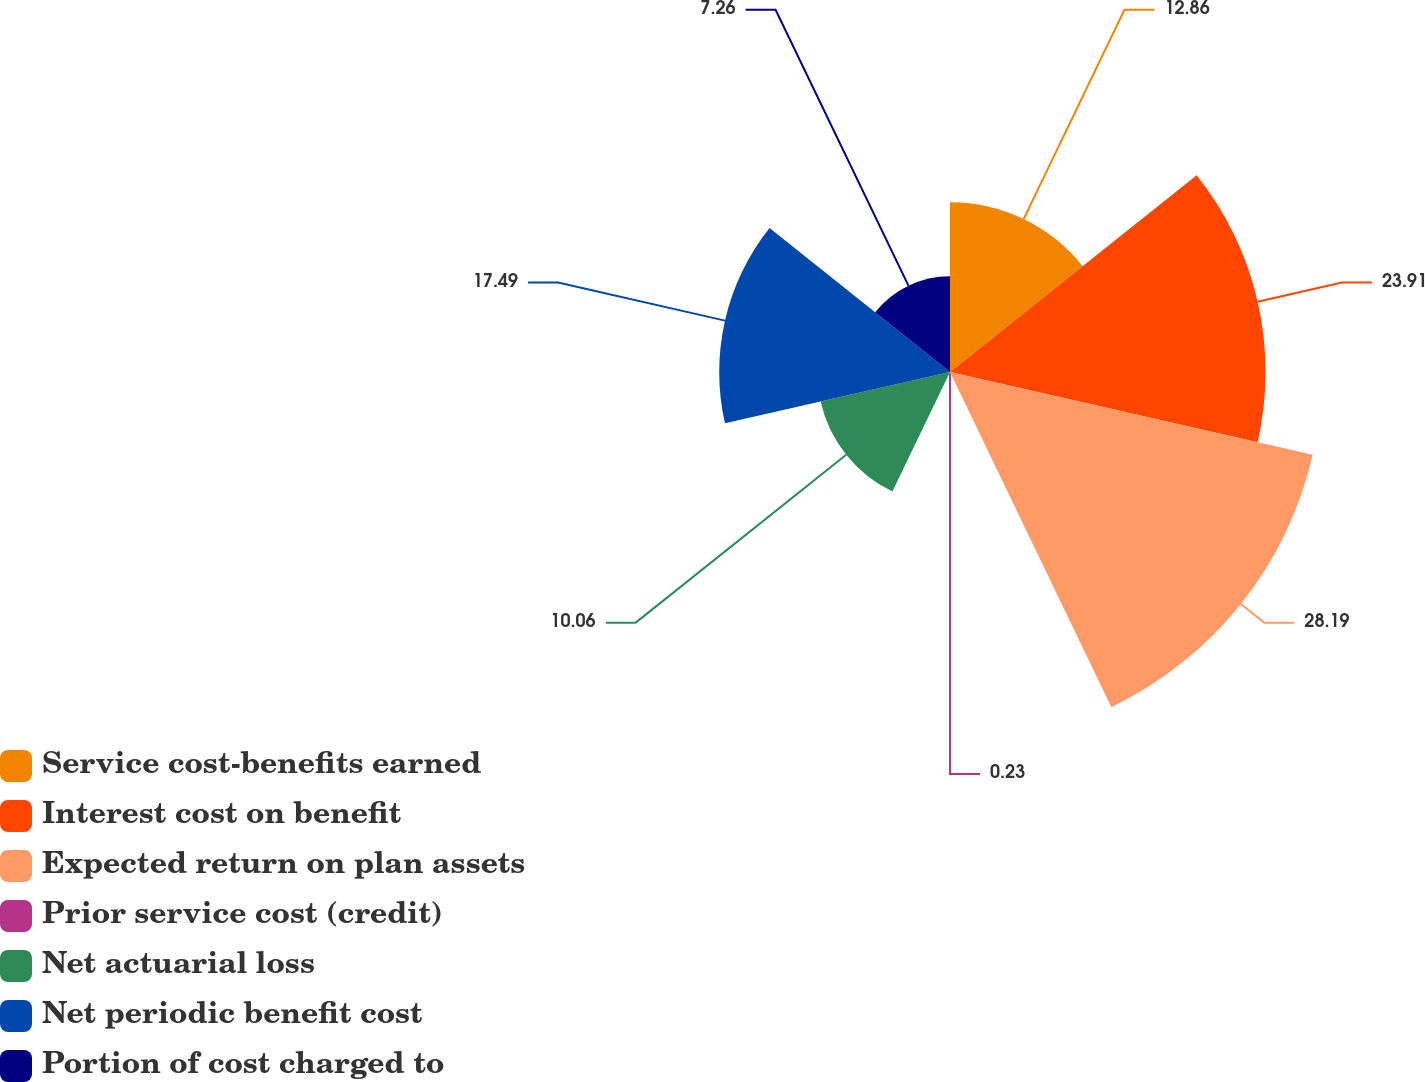Convert chart to OTSL. <chart><loc_0><loc_0><loc_500><loc_500><pie_chart><fcel>Service cost-benefits earned<fcel>Interest cost on benefit<fcel>Expected return on plan assets<fcel>Prior service cost (credit)<fcel>Net actuarial loss<fcel>Net periodic benefit cost<fcel>Portion of cost charged to<nl><fcel>12.86%<fcel>23.91%<fcel>28.19%<fcel>0.23%<fcel>10.06%<fcel>17.49%<fcel>7.26%<nl></chart> 